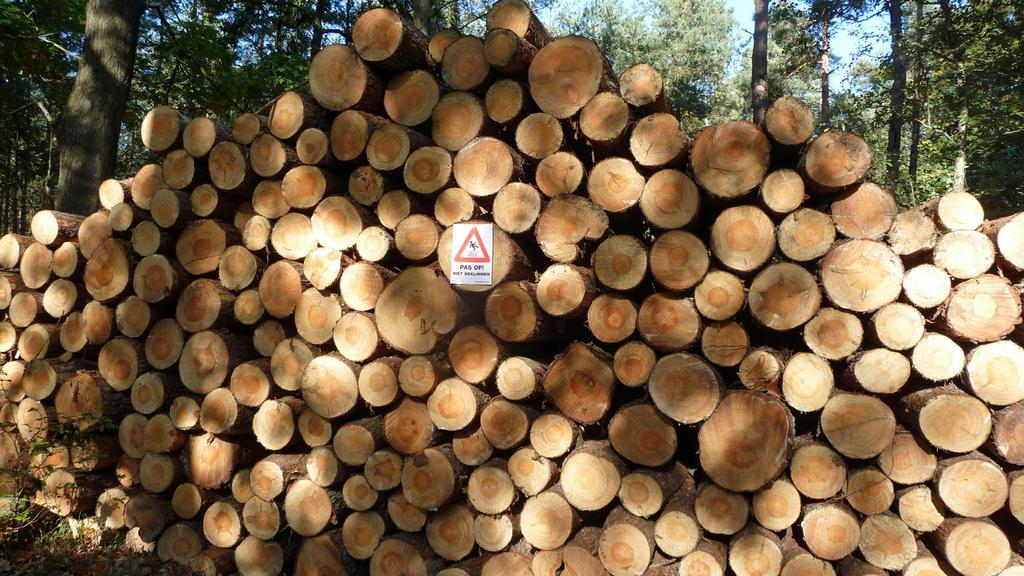Could you give a brief overview of what you see in this image? In this picture there are logs in the foreground and there is a board on the log and there is a text and sign on the board. At the back there are trees. At the top there is sky. At the bottom there is a plant. 